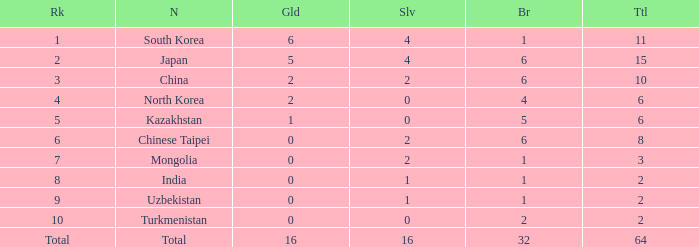Could you help me parse every detail presented in this table? {'header': ['Rk', 'N', 'Gld', 'Slv', 'Br', 'Ttl'], 'rows': [['1', 'South Korea', '6', '4', '1', '11'], ['2', 'Japan', '5', '4', '6', '15'], ['3', 'China', '2', '2', '6', '10'], ['4', 'North Korea', '2', '0', '4', '6'], ['5', 'Kazakhstan', '1', '0', '5', '6'], ['6', 'Chinese Taipei', '0', '2', '6', '8'], ['7', 'Mongolia', '0', '2', '1', '3'], ['8', 'India', '0', '1', '1', '2'], ['9', 'Uzbekistan', '0', '1', '1', '2'], ['10', 'Turkmenistan', '0', '0', '2', '2'], ['Total', 'Total', '16', '16', '32', '64']]} What is the total Gold's less than 0? 0.0. 